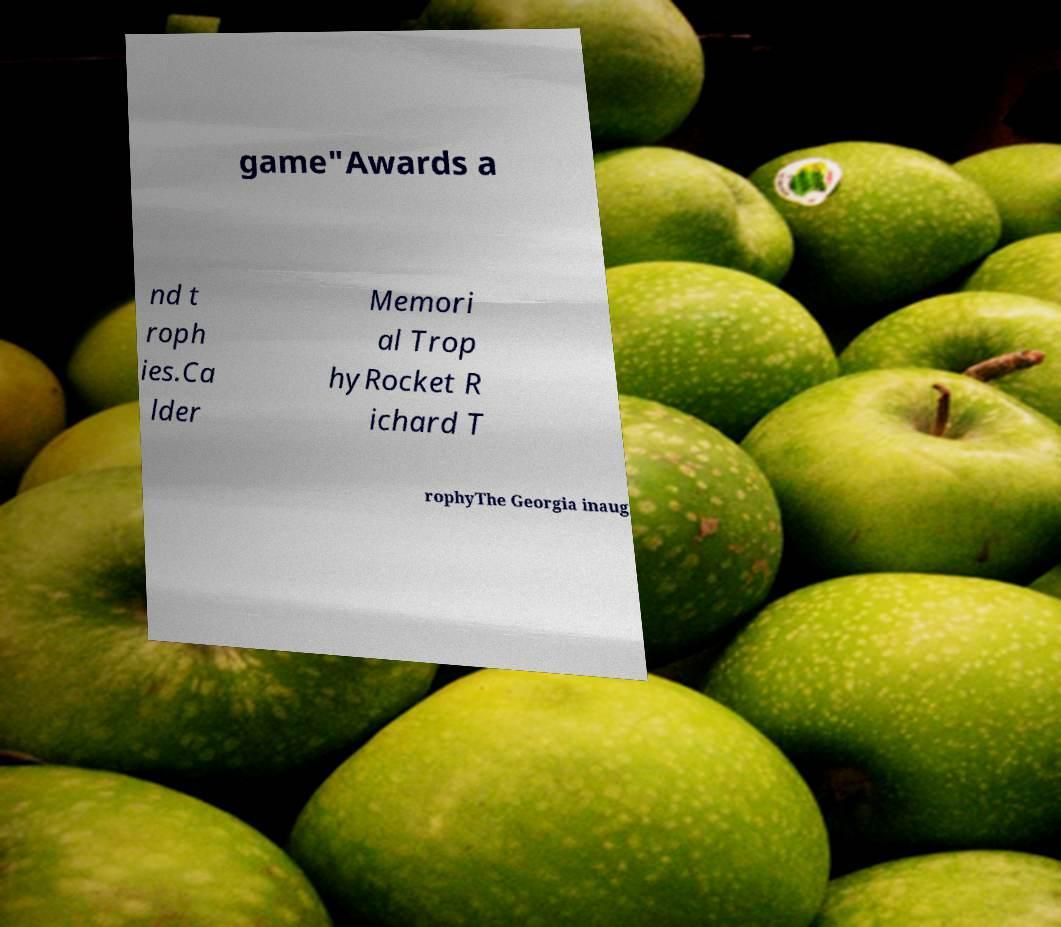For documentation purposes, I need the text within this image transcribed. Could you provide that? game"Awards a nd t roph ies.Ca lder Memori al Trop hyRocket R ichard T rophyThe Georgia inaug 